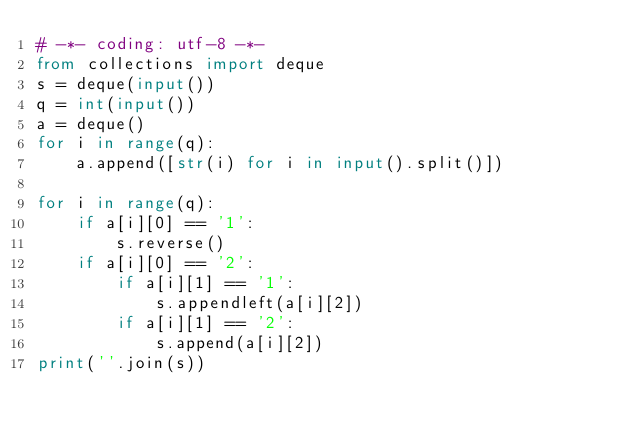Convert code to text. <code><loc_0><loc_0><loc_500><loc_500><_Python_># -*- coding: utf-8 -*-
from collections import deque
s = deque(input())
q = int(input())
a = deque()
for i in range(q):
    a.append([str(i) for i in input().split()])

for i in range(q):
    if a[i][0] == '1':
        s.reverse()
    if a[i][0] == '2':
        if a[i][1] == '1':
            s.appendleft(a[i][2])
        if a[i][1] == '2':
            s.append(a[i][2])
print(''.join(s))
</code> 